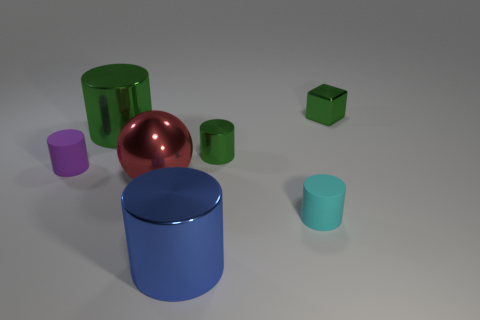Subtract all blue cylinders. How many cylinders are left? 4 Subtract 1 cylinders. How many cylinders are left? 4 Subtract all small metal cylinders. How many cylinders are left? 4 Subtract all red cylinders. Subtract all blue cubes. How many cylinders are left? 5 Add 2 large green things. How many objects exist? 9 Subtract all spheres. How many objects are left? 6 Subtract all tiny metal objects. Subtract all small metallic objects. How many objects are left? 3 Add 6 green cylinders. How many green cylinders are left? 8 Add 5 blue shiny spheres. How many blue shiny spheres exist? 5 Subtract 0 gray cylinders. How many objects are left? 7 